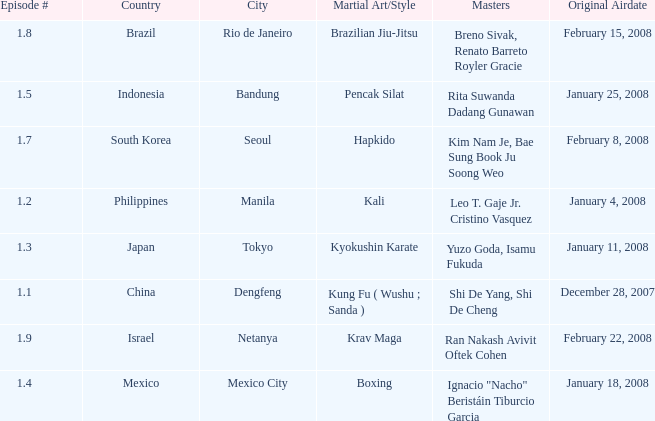How many masters fought using a boxing style? 1.0. 